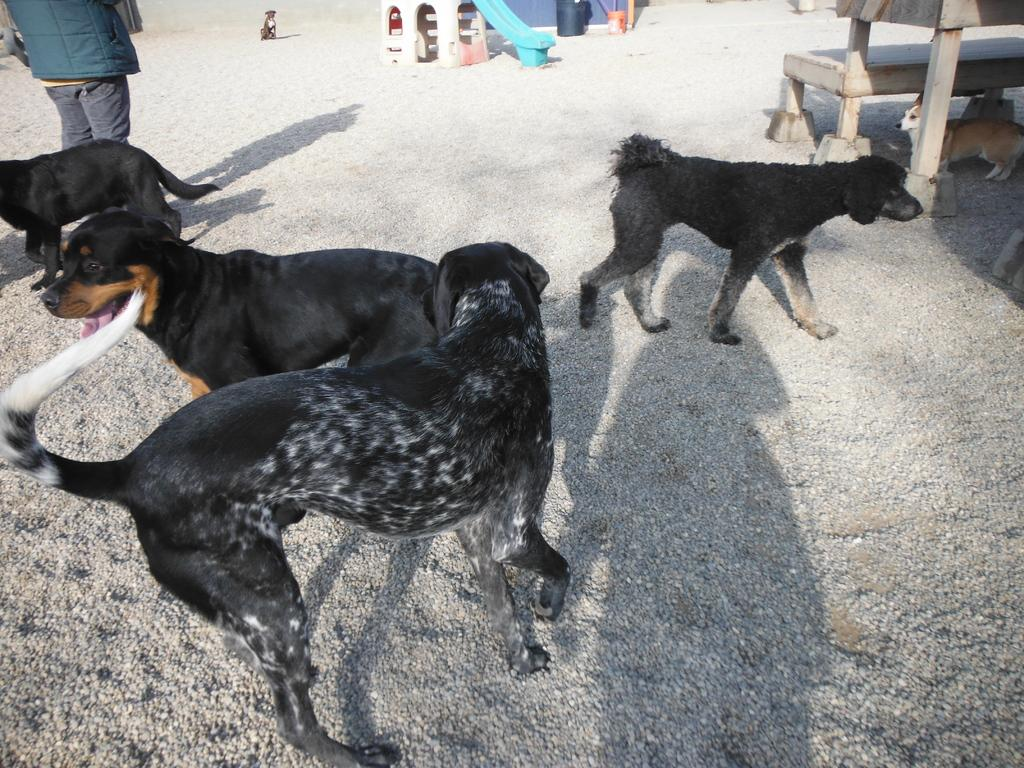What type of animals are in the image? There are dogs in the image. What piece of furniture is present in the image? There is a bench in the image. Are there any people in the image? Yes, there is a person in the image. What type of farm animals can be seen in the image? There are no farm animals present in the image; it features dogs and a person. Where is the train station located in the image? There is no train station or any reference to trains in the image. 